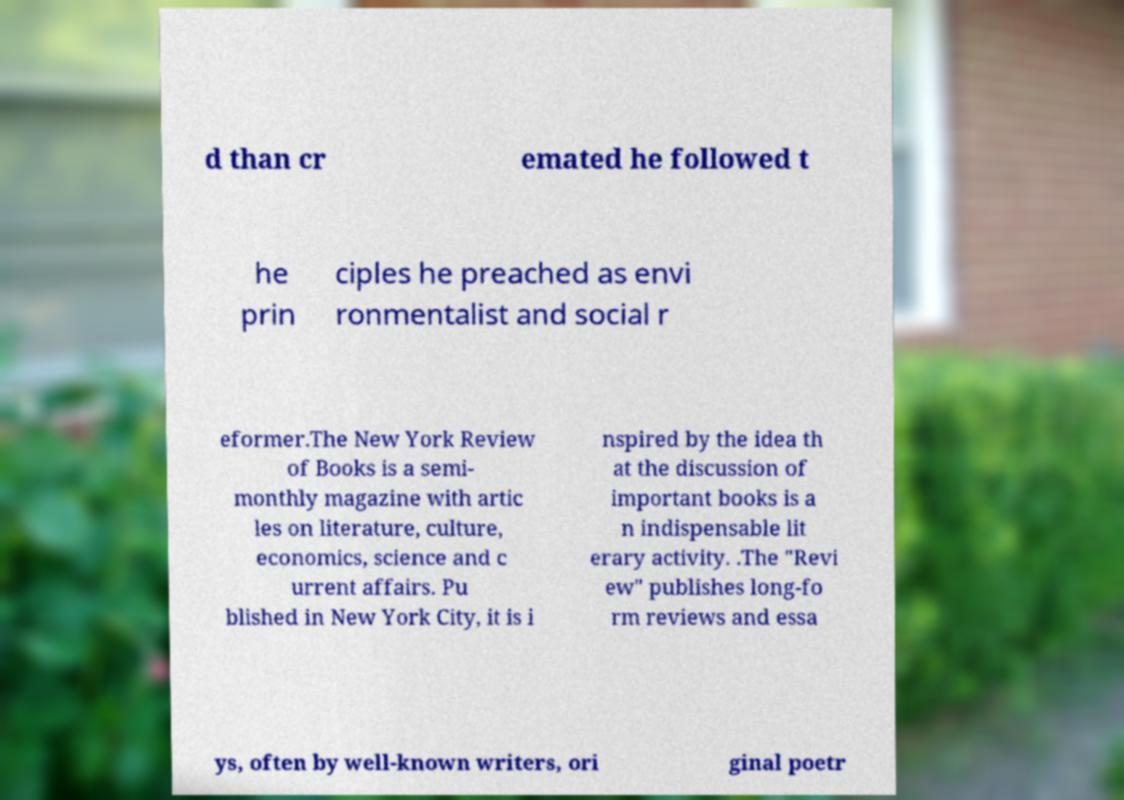I need the written content from this picture converted into text. Can you do that? d than cr emated he followed t he prin ciples he preached as envi ronmentalist and social r eformer.The New York Review of Books is a semi- monthly magazine with artic les on literature, culture, economics, science and c urrent affairs. Pu blished in New York City, it is i nspired by the idea th at the discussion of important books is a n indispensable lit erary activity. .The "Revi ew" publishes long-fo rm reviews and essa ys, often by well-known writers, ori ginal poetr 